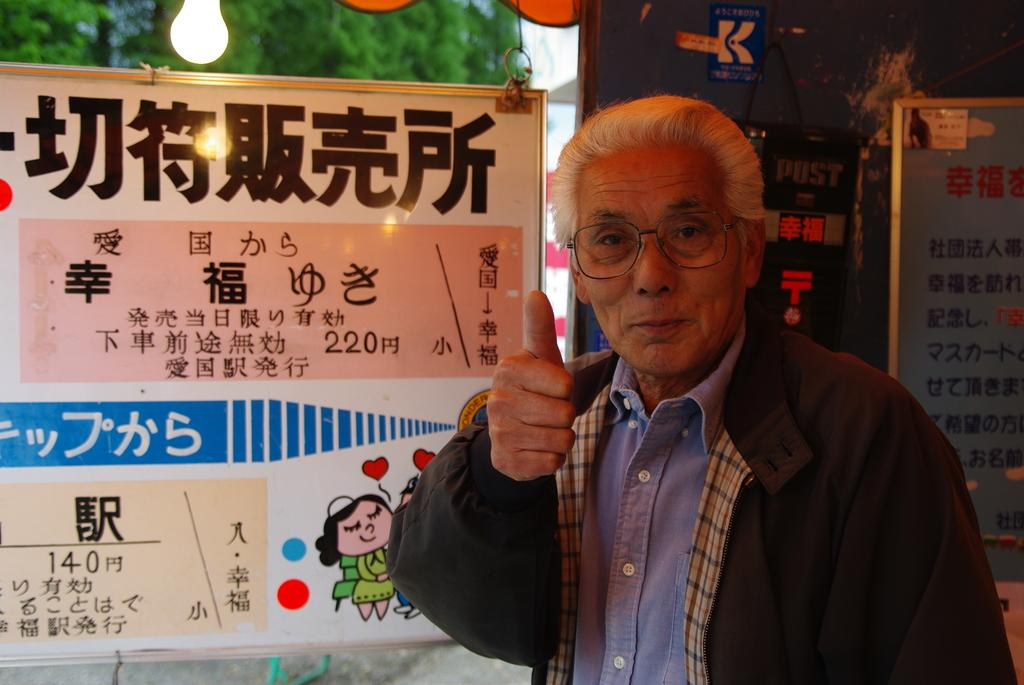Who is present in the image? There is a man in the image. What is the man's facial expression? The man is smiling. What accessory is the man wearing? The man is wearing spectacles. What can be seen in the background of the image? There are boards, light, and trees visible in the background of the image. What type of knowledge can be gained from the book in the image? There is no book present in the image, so no knowledge can be gained from a book in this context. 